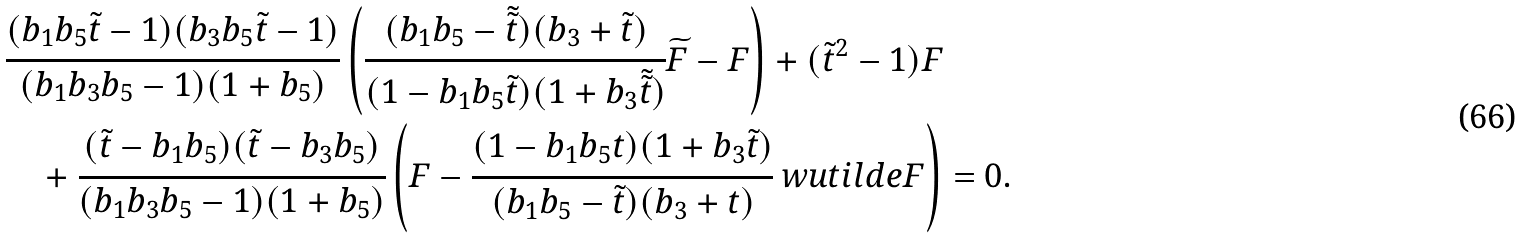Convert formula to latex. <formula><loc_0><loc_0><loc_500><loc_500>& \cfrac { ( b _ { 1 } b _ { 5 } \tilde { t } - 1 ) ( b _ { 3 } b _ { 5 } \tilde { t } - 1 ) } { ( b _ { 1 } b _ { 3 } b _ { 5 } - 1 ) ( 1 + b _ { 5 } ) } \left ( \cfrac { ( b _ { 1 } b _ { 5 } - \tilde { \tilde { t } } ) ( b _ { 3 } + \tilde { t } ) } { ( 1 - b _ { 1 } b _ { 5 } \tilde { t } ) ( 1 + b _ { 3 } \tilde { \tilde { t } } ) } \widetilde { F } - F \right ) + ( \tilde { t } ^ { 2 } - 1 ) F \\ & \quad + \cfrac { ( \tilde { t } - b _ { 1 } b _ { 5 } ) ( \tilde { t } - b _ { 3 } b _ { 5 } ) } { ( b _ { 1 } b _ { 3 } b _ { 5 } - 1 ) ( 1 + b _ { 5 } ) } \left ( F - \cfrac { ( 1 - b _ { 1 } b _ { 5 } t ) ( 1 + b _ { 3 } \tilde { t } ) } { ( b _ { 1 } b _ { 5 } - \tilde { t } ) ( b _ { 3 } + t ) } \ w u t i l d e { F } \right ) = 0 .</formula> 